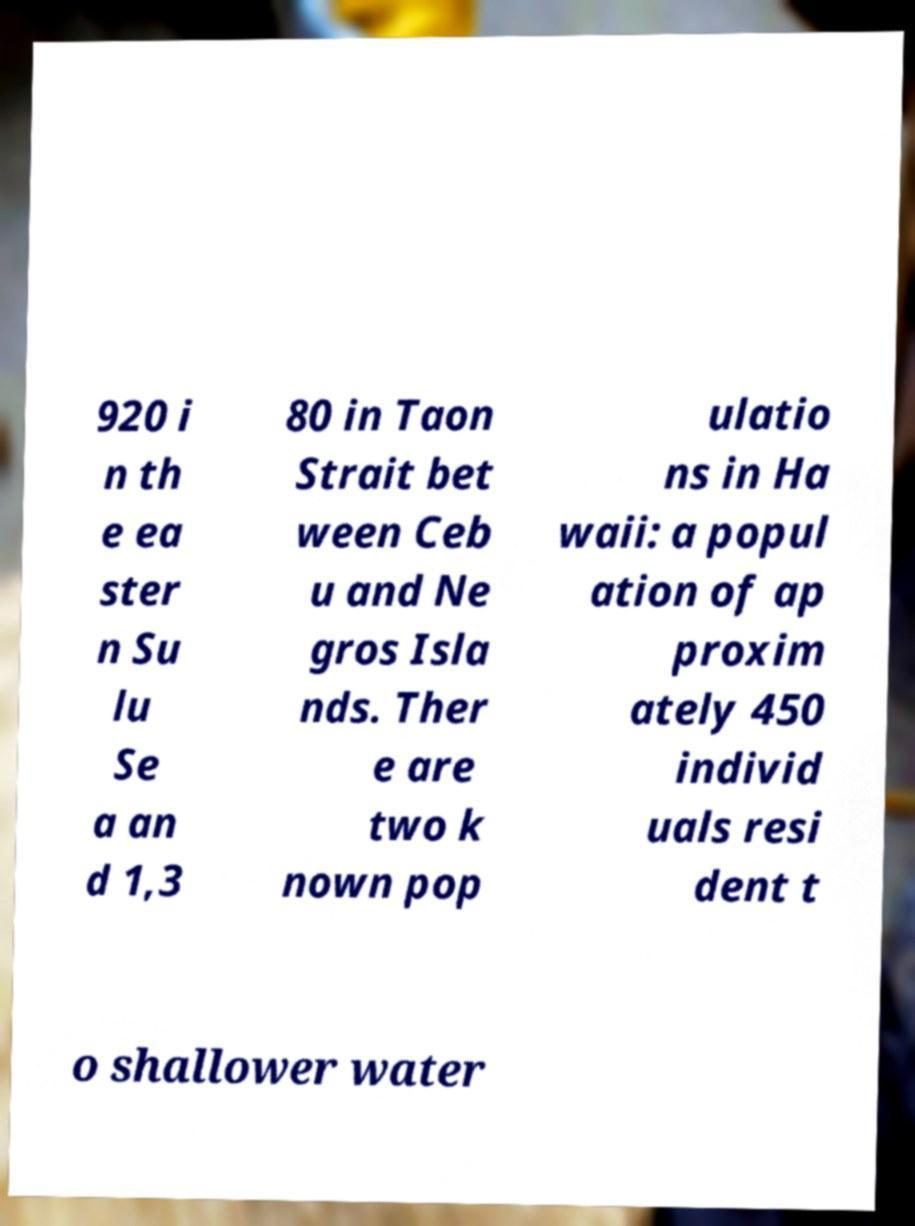Please identify and transcribe the text found in this image. 920 i n th e ea ster n Su lu Se a an d 1,3 80 in Taon Strait bet ween Ceb u and Ne gros Isla nds. Ther e are two k nown pop ulatio ns in Ha waii: a popul ation of ap proxim ately 450 individ uals resi dent t o shallower water 